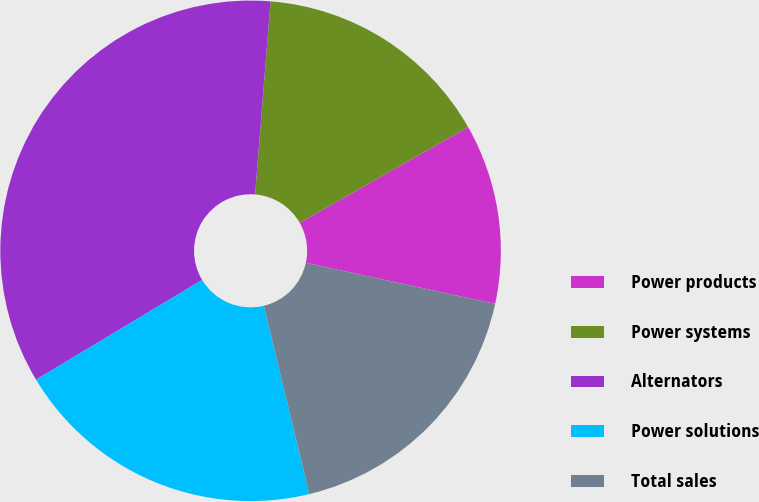<chart> <loc_0><loc_0><loc_500><loc_500><pie_chart><fcel>Power products<fcel>Power systems<fcel>Alternators<fcel>Power solutions<fcel>Total sales<nl><fcel>11.63%<fcel>15.5%<fcel>34.88%<fcel>20.16%<fcel>17.83%<nl></chart> 